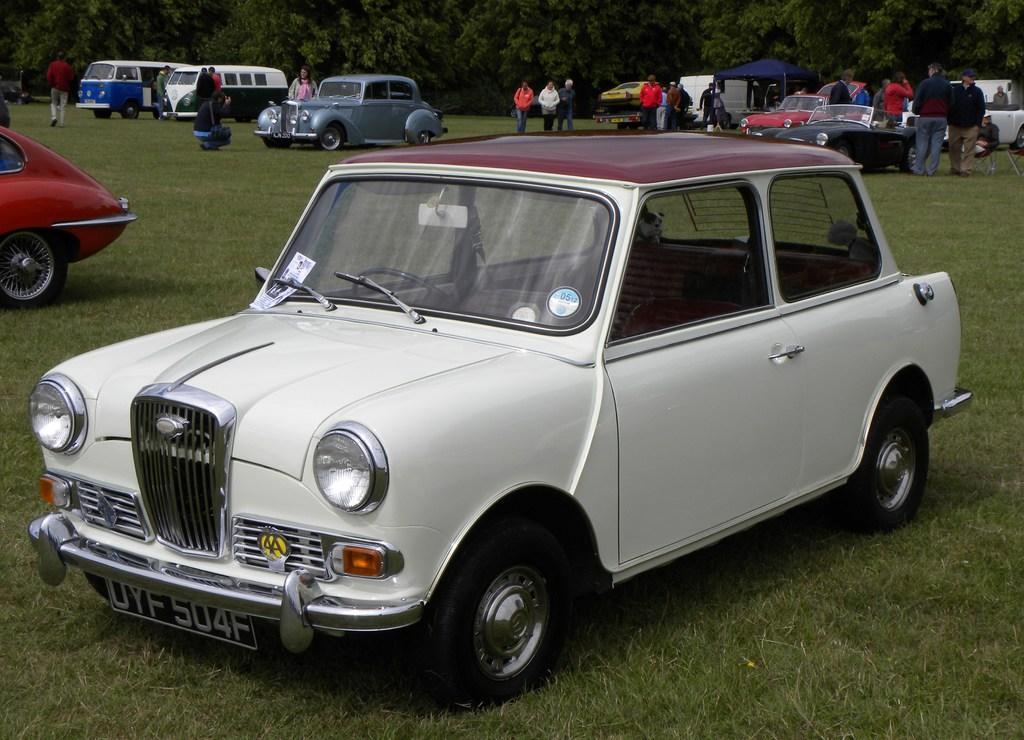Could you give a brief overview of what you see in this image? In this image we can see many vehicles. Also there are many people. On the ground there is grass. In the background there are trees. 